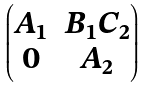<formula> <loc_0><loc_0><loc_500><loc_500>\begin{pmatrix} A _ { 1 } & B _ { 1 } C _ { 2 } \\ 0 & A _ { 2 } \end{pmatrix}</formula> 